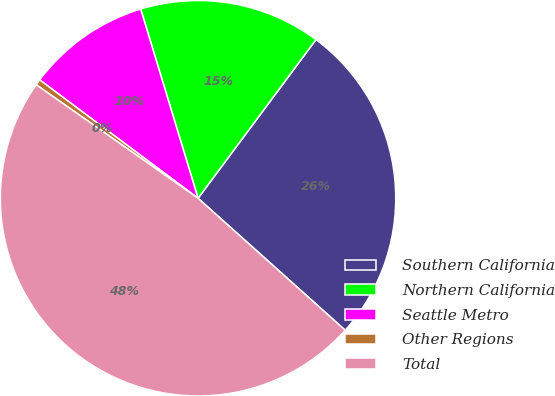Convert chart. <chart><loc_0><loc_0><loc_500><loc_500><pie_chart><fcel>Southern California<fcel>Northern California<fcel>Seattle Metro<fcel>Other Regions<fcel>Total<nl><fcel>26.46%<fcel>14.86%<fcel>10.1%<fcel>0.48%<fcel>48.1%<nl></chart> 